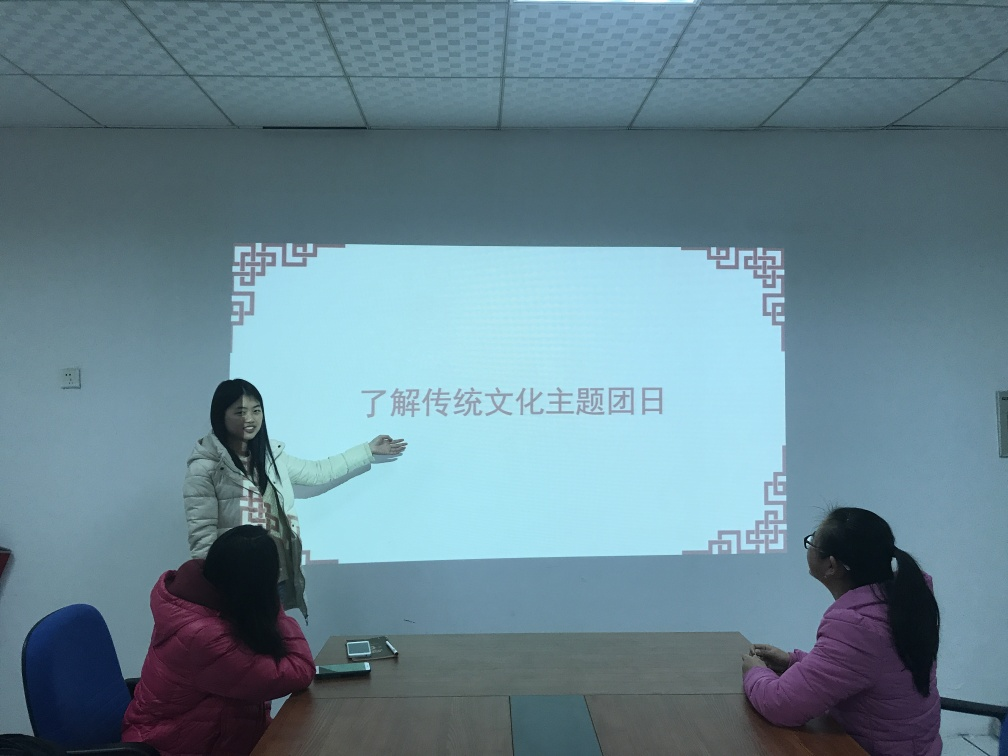Are the texture and details apparent in the image? The visual elements such as texture and details in the photograph are quite apparent. The image features crisp content where the text on the screen, the presenter's expression, and the audience's posture are all clearly visible, suggesting a well-lit and focused capture. 